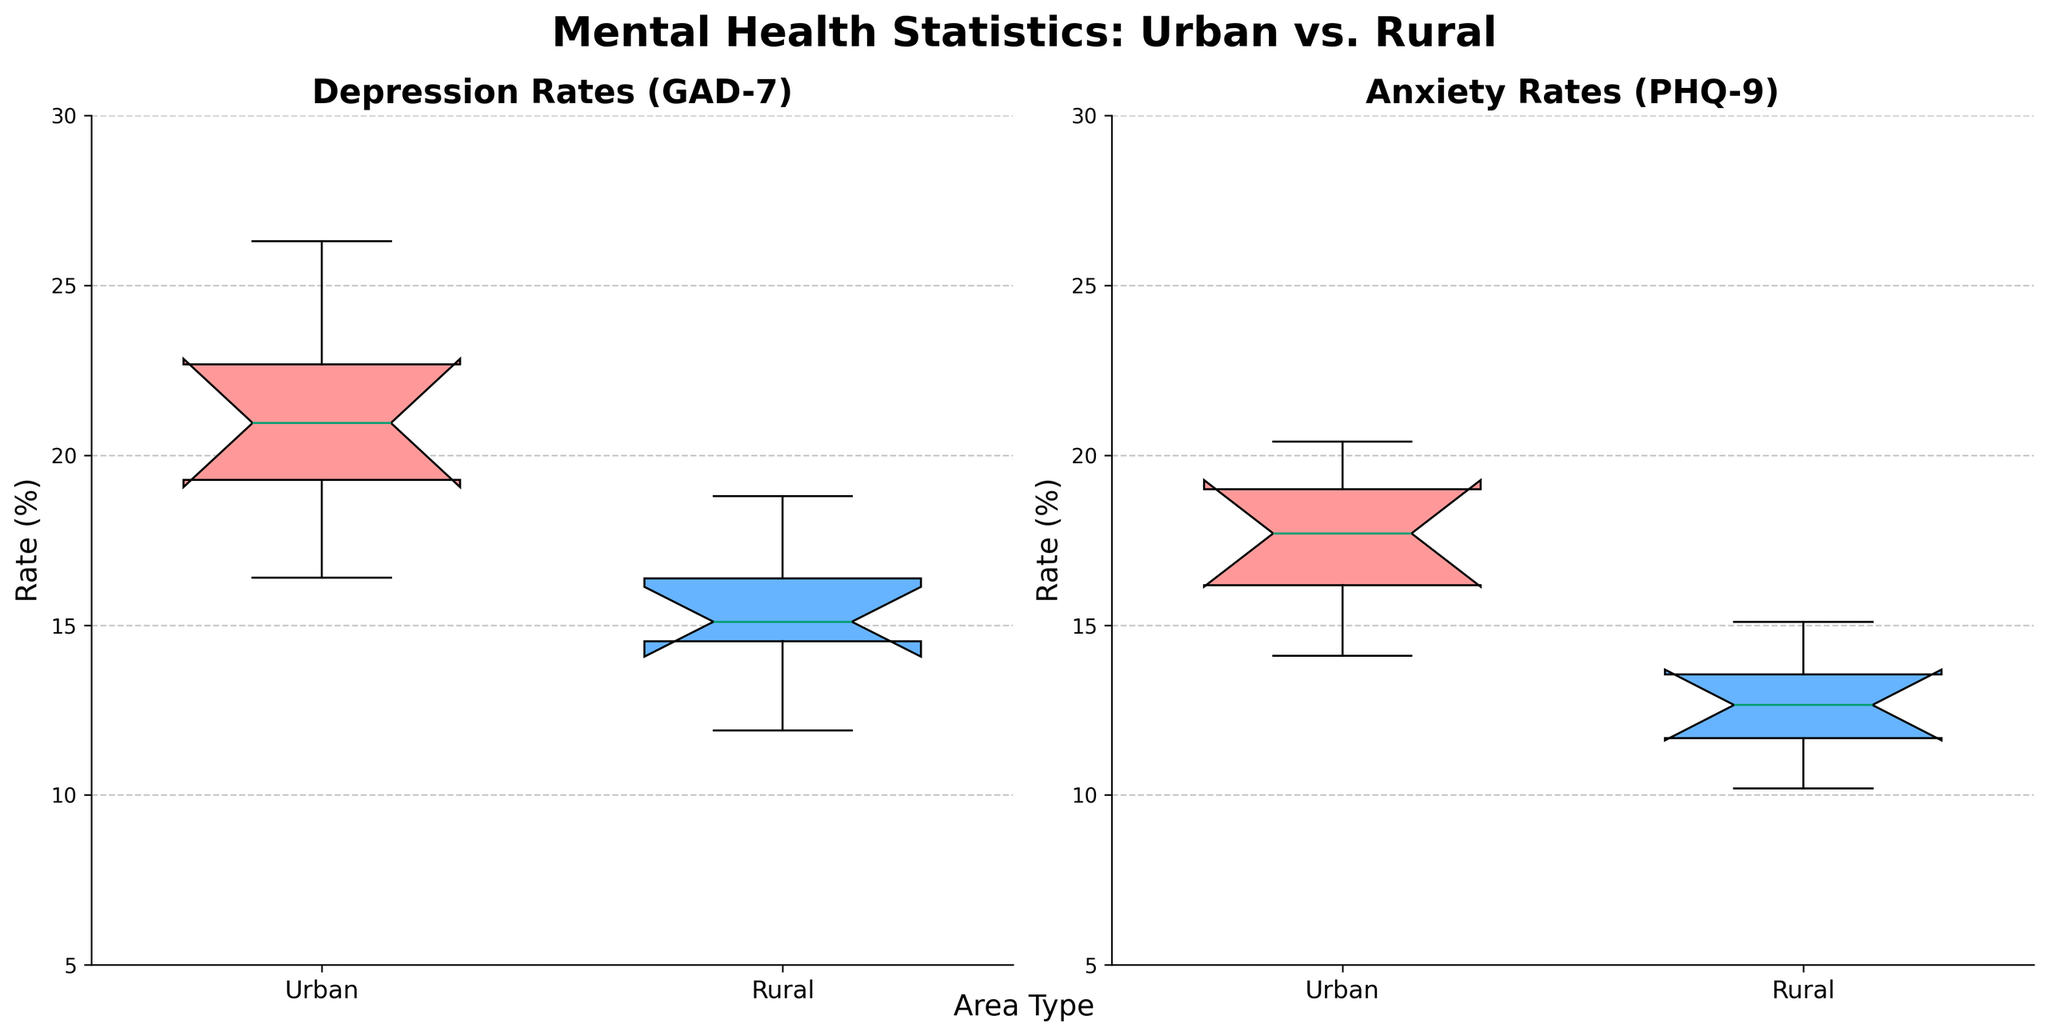What is the title of the figure? The title is usually placed at the top of the figure and describes its overall context. In this case, it is written in a large, bold font.
Answer: Mental Health Statistics: Urban vs. Rural What are the two conditions being compared for each country in the figure? The x-axis labels indicate the two conditions under comparison in the box plots. In this figure, the labels are "Urban" and "Rural".
Answer: Urban and Rural What are the two types of mental health rates shown in the figure? The titles above each of the two box plots indicate the different types of mental health rates. The left plot shows "Depression Rates (GAD-7)", and the right plot shows "Anxiety Rates (PHQ-9)".
Answer: Depression Rates and Anxiety Rates Which area, Urban or Rural, generally has higher rates of depression? By looking at the box plots for Depression Rates (GAD-7) on the left, we can see that the distributions of urban areas are higher across the plotted countries. Both the median and the spread of the urban group are higher.
Answer: Urban How do the median anxiety rates for Urban and Rural areas compare? The median is represented by the line within each box plot. By comparing the medians in the Anxiety Rates (PHQ-9) plot on the right side, we can see that the urban areas have a higher median rate than rural areas.
Answer: Urban is higher What is the range of depression rates in rural areas? The range is the difference between the maximum and minimum values within the box plot. For rural areas, the depression rates vary from just above 10% to around 19%.
Answer: Approximately 10-19% Is there more variation in depression rates or anxiety rates for urban areas? Variation can be assessed by the spread of the box plot. Urban areas show larger interquartile ranges and higher whiskers for depression rates in the left plot compared to anxiety rates in the right plot.
Answer: Depression rates have more variation Which country appears to have the highest anxiety rate in urban areas, and what is that rate? By reviewing the upper whisker or outlier values in the Anxiety Rates (PHQ-9) plot, the highest anxiety rate in urban areas corresponds to the data point representing India. The value is around 20.4%.
Answer: India, 20.4% Comparing depression rates, which area type (Urban/Rural) has the highest median, and what is that value? The median is represented by the line inside the box. By comparing them in the Depression Rates (GAD-7) plot, the urban area has the highest median value, which is just above 20%.
Answer: Urban, slightly above 20% Which area type shows a more pronounced variability in anxiety rates, and how do you conclude this? Variability can be determined by the interquartile range and the length of the whiskers in the box plots. The urban areas in the anxiety rates plot have larger boxes and whiskers, indicating more variability.
Answer: Urban, shows more variability 